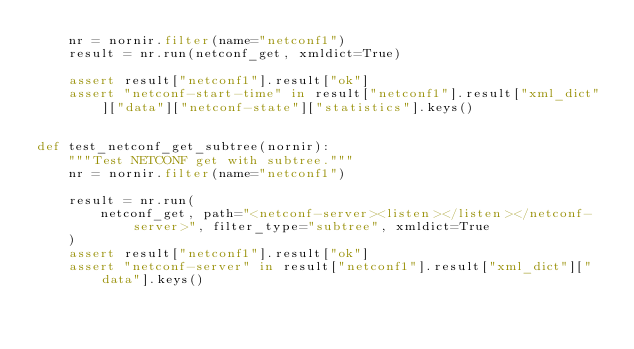<code> <loc_0><loc_0><loc_500><loc_500><_Python_>    nr = nornir.filter(name="netconf1")
    result = nr.run(netconf_get, xmldict=True)

    assert result["netconf1"].result["ok"]
    assert "netconf-start-time" in result["netconf1"].result["xml_dict"]["data"]["netconf-state"]["statistics"].keys()


def test_netconf_get_subtree(nornir):
    """Test NETCONF get with subtree."""
    nr = nornir.filter(name="netconf1")

    result = nr.run(
        netconf_get, path="<netconf-server><listen></listen></netconf-server>", filter_type="subtree", xmldict=True
    )
    assert result["netconf1"].result["ok"]
    assert "netconf-server" in result["netconf1"].result["xml_dict"]["data"].keys()
</code> 